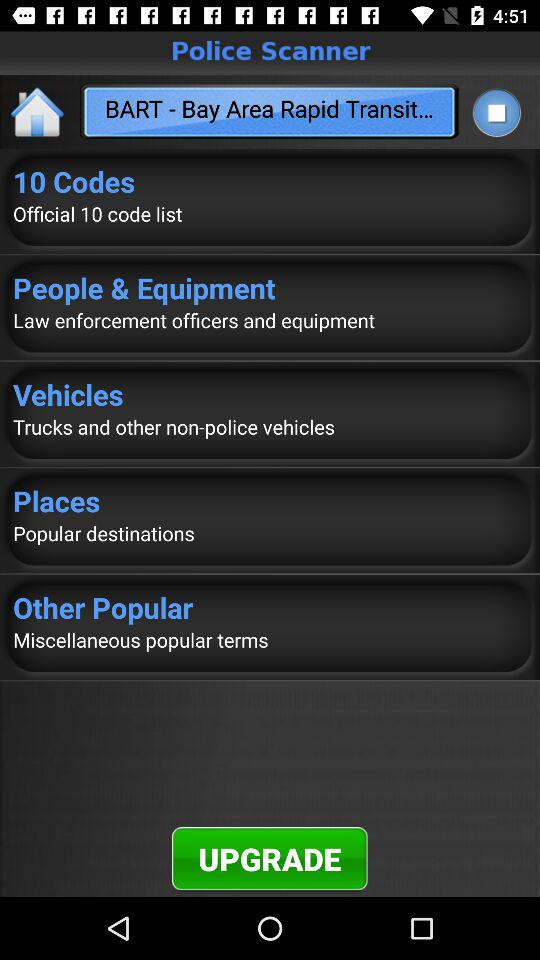What is the application name? The application name is "Police Scanner". 